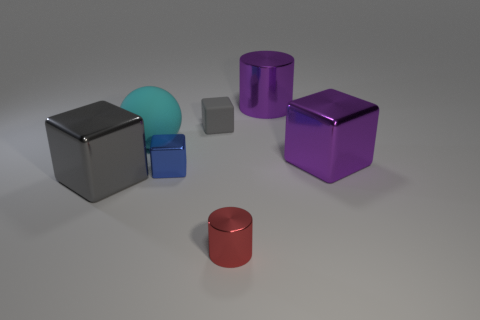What is the lighting like in this scene? Does it appear to be natural or artificial, and why? The lighting in the scene appears to be artificial based on the soft shadows cast by the objects and the diffused illumination. There is no indication of a natural light source such as the sun, and the lack of a visible environment suggests studio lighting conditions. 